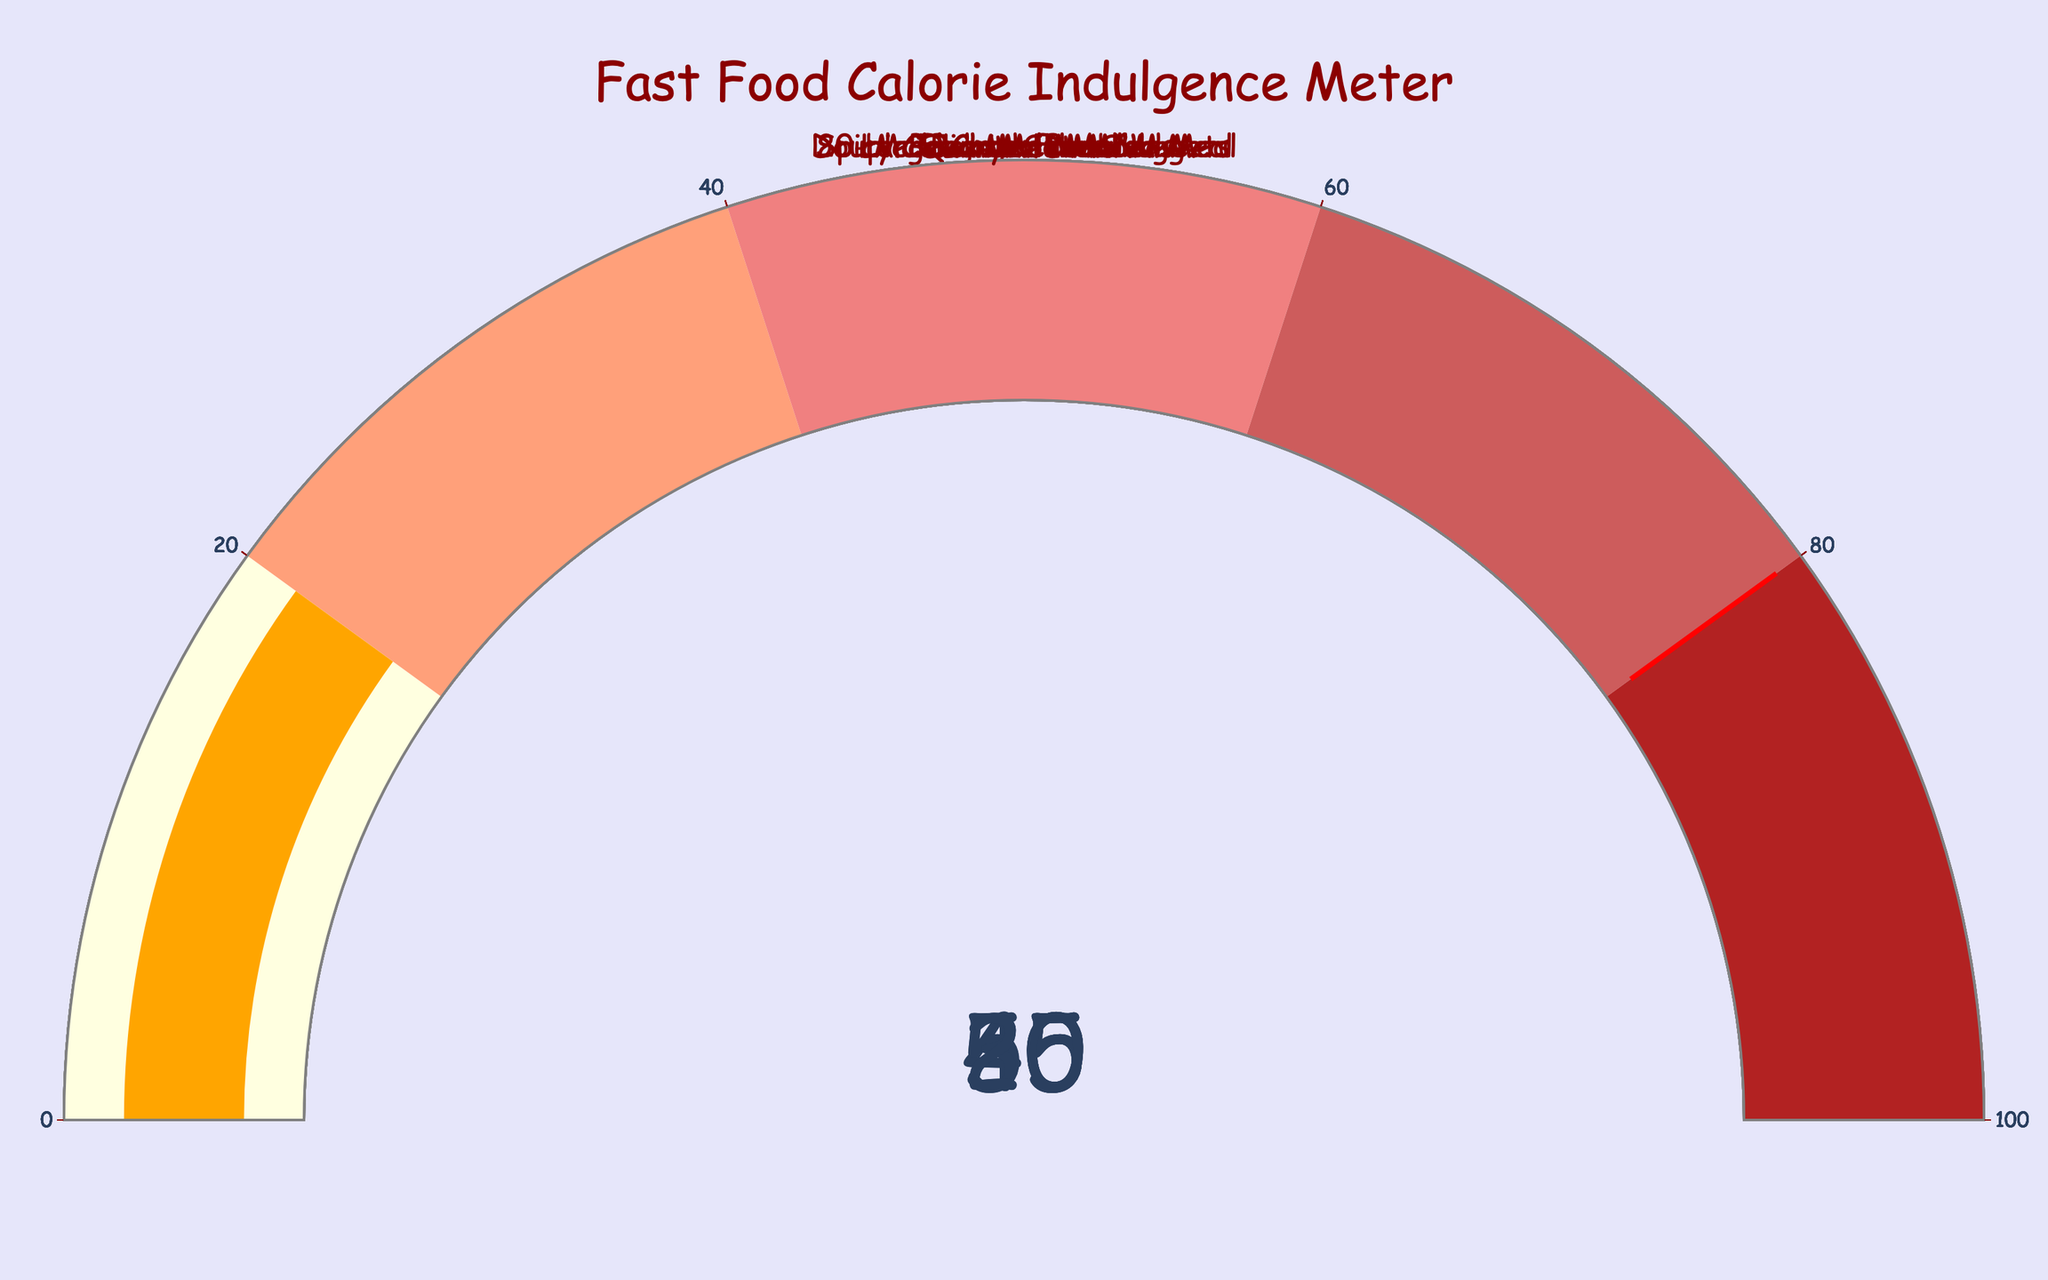What's the title of the figure? The title is typically found at the top of the figure, and in this case, it reads, "Fast Food Calorie Indulgence Meter."
Answer: Fast Food Calorie Indulgence Meter Which meal has the highest daily calorie intake percentage? By examining the gauge charts, it is clear that the "Double Quarter Pounder Meal" has the highest percentage at 55%.
Answer: Double Quarter Pounder Meal How many meals exceed 40% of the recommended daily calorie intake? By counting the number of gauges that have values above 40%, there are four meals: "Big Mac Meal," "Double Quarter Pounder Meal," "Spicy Chicken Sandwich Meal," and "20-piece Chicken McNuggets."
Answer: Four What's the average daily calorie percentage for all meals? Add up all the percentages: 45 + 55 + 40 + 25 + 30 + 50 + 35 + 20 = 300, then divide by the number of items (8): 300/8 = 37.5.
Answer: 37.5 Which meal has the lowest daily calorie intake percentage? By examining the gauge charts, the "McFlurry with M&Ms" has the lowest percentage at 20%.
Answer: McFlurry with M&Ms How much higher is the daily calorie percentage of the Double Quarter Pounder Meal compared to the Bacon McDouble? The Double Quarter Pounder Meal is at 55%, while the Bacon McDouble is at 35%. The difference is 55 - 35 = 20%.
Answer: 20% Which foods fall into the 'lightcoral' color range on the gauge (40-60%)? The foods that fall into the 'lightcoral' range are "Big Mac Meal," "Double Quarter Pounder Meal," "Spicy Chicken Sandwich Meal," and "20-piece Chicken McNuggets."
Answer: Big Mac Meal, Double Quarter Pounder Meal, Spicy Chicken Sandwich Meal, 20-piece Chicken McNuggets If you combine the daily calorie percentages for "Large Fries" and "Large Chocolate Shake," does the total exceed 50%? Add the percentages for "Large Fries" (25%) and "Large Chocolate Shake" (30%): 25 + 30 = 55%, which exceeds 50%.
Answer: Yes How does the daily calorie percentage of "Spicy Chicken Sandwich Meal" compare to "Bacon McDouble"? The "Spicy Chicken Sandwich Meal" is at 40%, while the "Bacon McDouble" is at 35%. The "Spicy Chicken Sandwich Meal" has a higher percentage by 5%.
Answer: 5% higher 